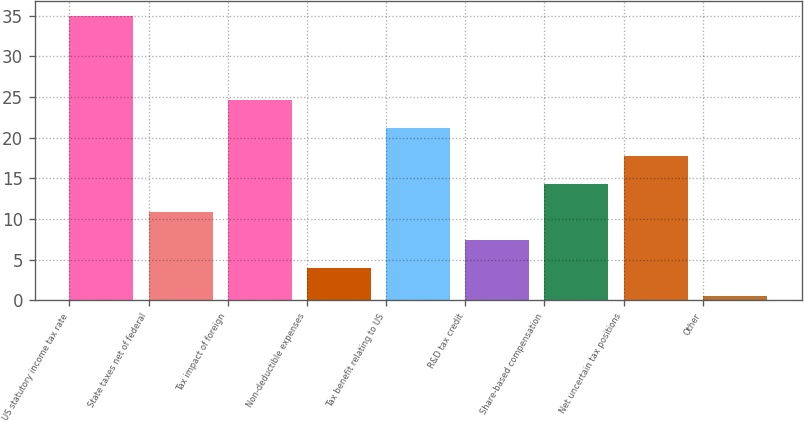Convert chart. <chart><loc_0><loc_0><loc_500><loc_500><bar_chart><fcel>US statutory income tax rate<fcel>State taxes net of federal<fcel>Tax impact of foreign<fcel>Non-deductible expenses<fcel>Tax benefit relating to US<fcel>R&D tax credit<fcel>Share-based compensation<fcel>Net uncertain tax positions<fcel>Other<nl><fcel>35<fcel>10.92<fcel>24.68<fcel>4.04<fcel>21.24<fcel>7.48<fcel>14.36<fcel>17.8<fcel>0.6<nl></chart> 